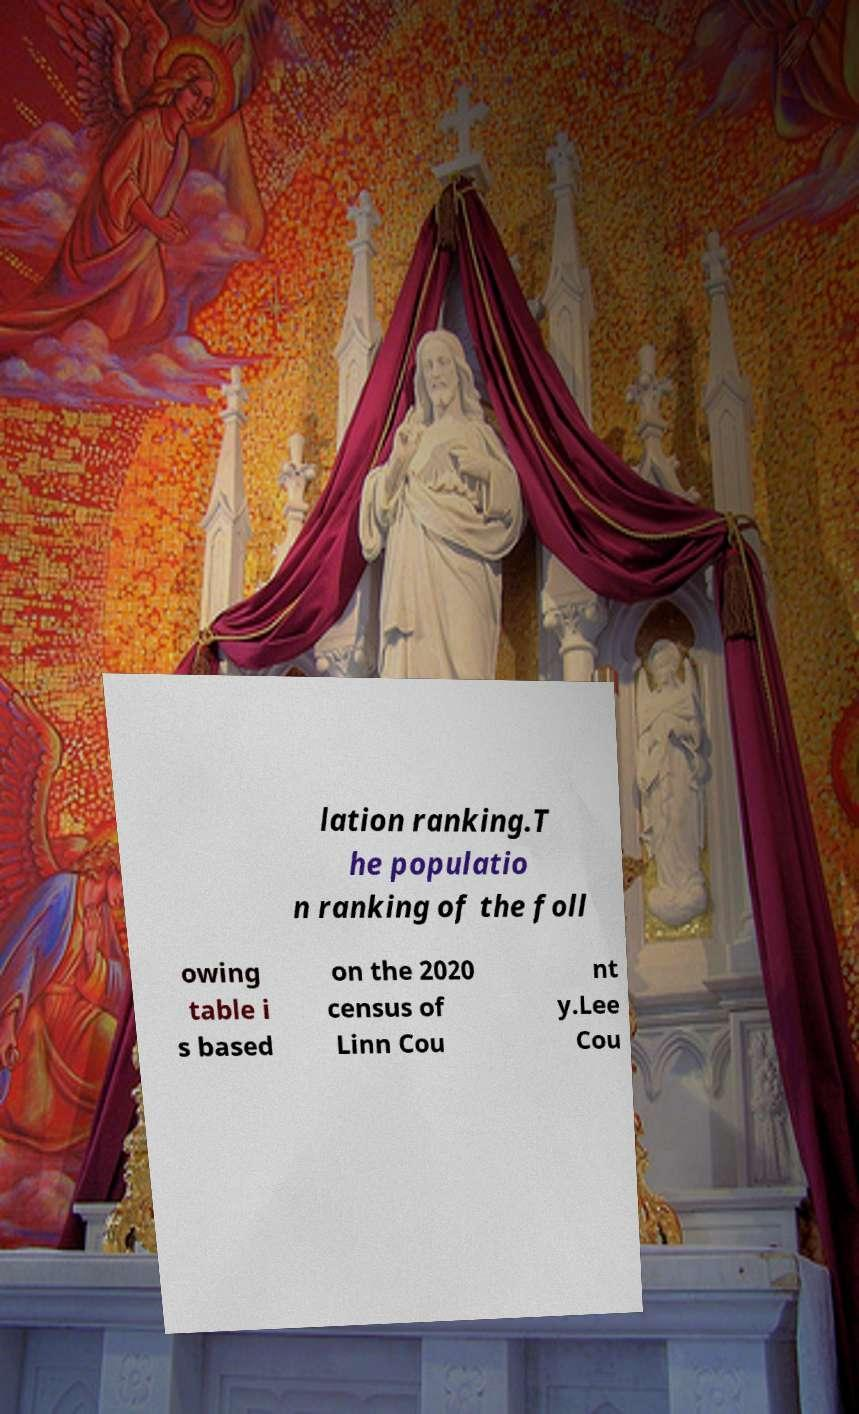Please identify and transcribe the text found in this image. lation ranking.T he populatio n ranking of the foll owing table i s based on the 2020 census of Linn Cou nt y.Lee Cou 